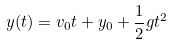Convert formula to latex. <formula><loc_0><loc_0><loc_500><loc_500>y ( t ) = v _ { 0 } t + y _ { 0 } + { \frac { 1 } { 2 } } g t ^ { 2 }</formula> 